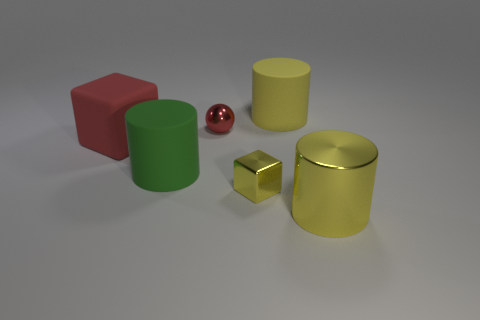Is there a pattern to the arrangement of the objects? The objects are arranged with no apparent pattern; they are scattered in such a way that there's a mix of shapes, sizes, and colors distributed across the surface with no discernible regularity. 